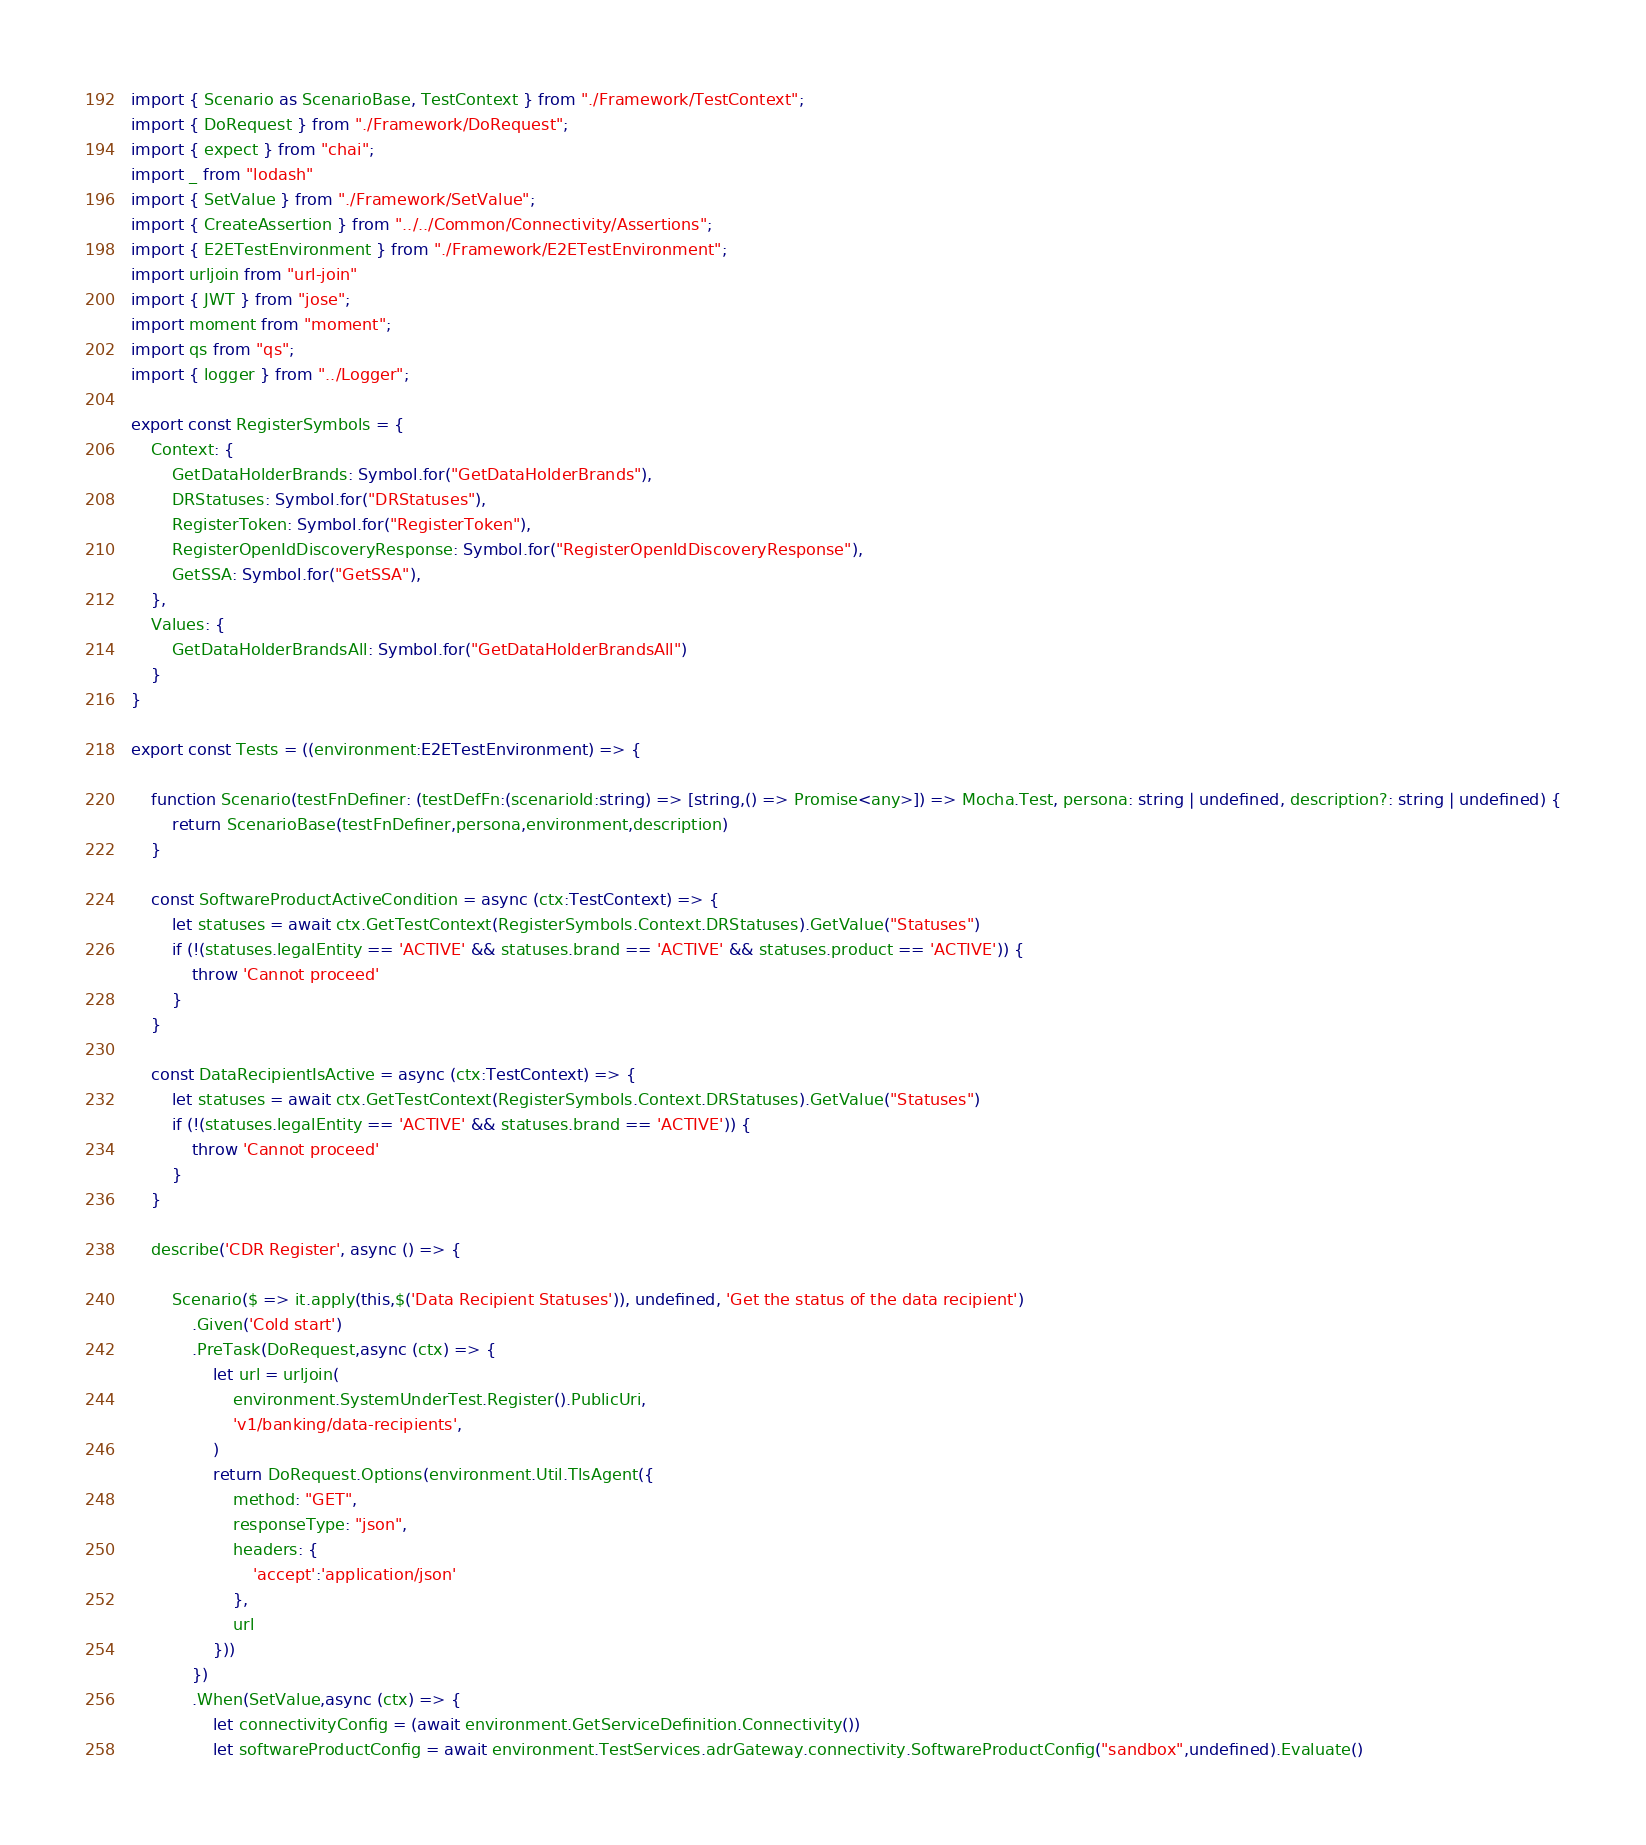Convert code to text. <code><loc_0><loc_0><loc_500><loc_500><_TypeScript_>import { Scenario as ScenarioBase, TestContext } from "./Framework/TestContext";
import { DoRequest } from "./Framework/DoRequest";
import { expect } from "chai";
import _ from "lodash"
import { SetValue } from "./Framework/SetValue";
import { CreateAssertion } from "../../Common/Connectivity/Assertions";
import { E2ETestEnvironment } from "./Framework/E2ETestEnvironment";
import urljoin from "url-join"
import { JWT } from "jose";
import moment from "moment";
import qs from "qs";
import { logger } from "../Logger";

export const RegisterSymbols = {
    Context: {
        GetDataHolderBrands: Symbol.for("GetDataHolderBrands"),
        DRStatuses: Symbol.for("DRStatuses"),
        RegisterToken: Symbol.for("RegisterToken"),
        RegisterOpenIdDiscoveryResponse: Symbol.for("RegisterOpenIdDiscoveryResponse"),
        GetSSA: Symbol.for("GetSSA"),
    },
    Values: {
        GetDataHolderBrandsAll: Symbol.for("GetDataHolderBrandsAll")    
    }
}

export const Tests = ((environment:E2ETestEnvironment) => {

    function Scenario(testFnDefiner: (testDefFn:(scenarioId:string) => [string,() => Promise<any>]) => Mocha.Test, persona: string | undefined, description?: string | undefined) {
        return ScenarioBase(testFnDefiner,persona,environment,description)
    }

    const SoftwareProductActiveCondition = async (ctx:TestContext) => {
        let statuses = await ctx.GetTestContext(RegisterSymbols.Context.DRStatuses).GetValue("Statuses")
        if (!(statuses.legalEntity == 'ACTIVE' && statuses.brand == 'ACTIVE' && statuses.product == 'ACTIVE')) {
            throw 'Cannot proceed'
        }
    }

    const DataRecipientIsActive = async (ctx:TestContext) => {
        let statuses = await ctx.GetTestContext(RegisterSymbols.Context.DRStatuses).GetValue("Statuses")
        if (!(statuses.legalEntity == 'ACTIVE' && statuses.brand == 'ACTIVE')) {
            throw 'Cannot proceed'
        }
    }

    describe('CDR Register', async () => {

        Scenario($ => it.apply(this,$('Data Recipient Statuses')), undefined, 'Get the status of the data recipient')
            .Given('Cold start')
            .PreTask(DoRequest,async (ctx) => {
                let url = urljoin(
                    environment.SystemUnderTest.Register().PublicUri,
                    'v1/banking/data-recipients',
                )
                return DoRequest.Options(environment.Util.TlsAgent({
                    method: "GET",
                    responseType: "json",
                    headers: {
                        'accept':'application/json'
                    },
                    url
                }))
            })
            .When(SetValue,async (ctx) => {
                let connectivityConfig = (await environment.GetServiceDefinition.Connectivity())
                let softwareProductConfig = await environment.TestServices.adrGateway.connectivity.SoftwareProductConfig("sandbox",undefined).Evaluate()
</code> 